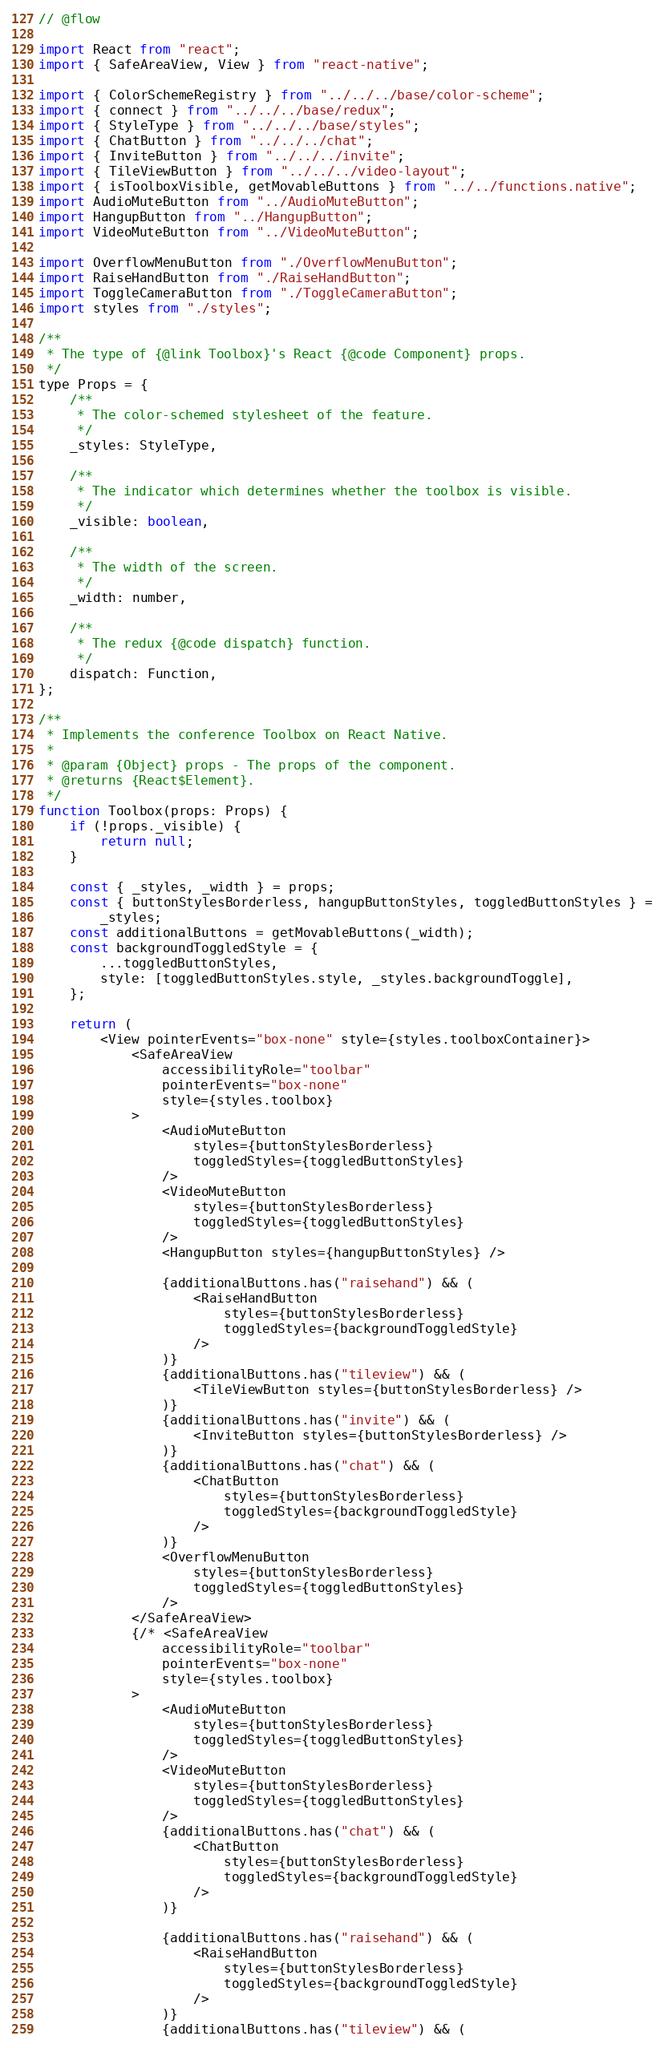Convert code to text. <code><loc_0><loc_0><loc_500><loc_500><_JavaScript_>// @flow

import React from "react";
import { SafeAreaView, View } from "react-native";

import { ColorSchemeRegistry } from "../../../base/color-scheme";
import { connect } from "../../../base/redux";
import { StyleType } from "../../../base/styles";
import { ChatButton } from "../../../chat";
import { InviteButton } from "../../../invite";
import { TileViewButton } from "../../../video-layout";
import { isToolboxVisible, getMovableButtons } from "../../functions.native";
import AudioMuteButton from "../AudioMuteButton";
import HangupButton from "../HangupButton";
import VideoMuteButton from "../VideoMuteButton";

import OverflowMenuButton from "./OverflowMenuButton";
import RaiseHandButton from "./RaiseHandButton";
import ToggleCameraButton from "./ToggleCameraButton";
import styles from "./styles";

/**
 * The type of {@link Toolbox}'s React {@code Component} props.
 */
type Props = {
    /**
     * The color-schemed stylesheet of the feature.
     */
    _styles: StyleType,

    /**
     * The indicator which determines whether the toolbox is visible.
     */
    _visible: boolean,

    /**
     * The width of the screen.
     */
    _width: number,

    /**
     * The redux {@code dispatch} function.
     */
    dispatch: Function,
};

/**
 * Implements the conference Toolbox on React Native.
 *
 * @param {Object} props - The props of the component.
 * @returns {React$Element}.
 */
function Toolbox(props: Props) {
    if (!props._visible) {
        return null;
    }

    const { _styles, _width } = props;
    const { buttonStylesBorderless, hangupButtonStyles, toggledButtonStyles } =
        _styles;
    const additionalButtons = getMovableButtons(_width);
    const backgroundToggledStyle = {
        ...toggledButtonStyles,
        style: [toggledButtonStyles.style, _styles.backgroundToggle],
    };

    return (
        <View pointerEvents="box-none" style={styles.toolboxContainer}>
            <SafeAreaView
                accessibilityRole="toolbar"
                pointerEvents="box-none"
                style={styles.toolbox}
            >
                <AudioMuteButton
                    styles={buttonStylesBorderless}
                    toggledStyles={toggledButtonStyles}
                />
                <VideoMuteButton
                    styles={buttonStylesBorderless}
                    toggledStyles={toggledButtonStyles}
                />
                <HangupButton styles={hangupButtonStyles} />

                {additionalButtons.has("raisehand") && (
                    <RaiseHandButton
                        styles={buttonStylesBorderless}
                        toggledStyles={backgroundToggledStyle}
                    />
                )}
                {additionalButtons.has("tileview") && (
                    <TileViewButton styles={buttonStylesBorderless} />
                )}
                {additionalButtons.has("invite") && (
                    <InviteButton styles={buttonStylesBorderless} />
                )}
                {additionalButtons.has("chat") && (
                    <ChatButton
                        styles={buttonStylesBorderless}
                        toggledStyles={backgroundToggledStyle}
                    />
                )}
                <OverflowMenuButton
                    styles={buttonStylesBorderless}
                    toggledStyles={toggledButtonStyles}
                />
            </SafeAreaView>
            {/* <SafeAreaView
                accessibilityRole="toolbar"
                pointerEvents="box-none"
                style={styles.toolbox}
            >
                <AudioMuteButton
                    styles={buttonStylesBorderless}
                    toggledStyles={toggledButtonStyles}
                />
                <VideoMuteButton
                    styles={buttonStylesBorderless}
                    toggledStyles={toggledButtonStyles}
                />
                {additionalButtons.has("chat") && (
                    <ChatButton
                        styles={buttonStylesBorderless}
                        toggledStyles={backgroundToggledStyle}
                    />
                )}

                {additionalButtons.has("raisehand") && (
                    <RaiseHandButton
                        styles={buttonStylesBorderless}
                        toggledStyles={backgroundToggledStyle}
                    />
                )}
                {additionalButtons.has("tileview") && (</code> 